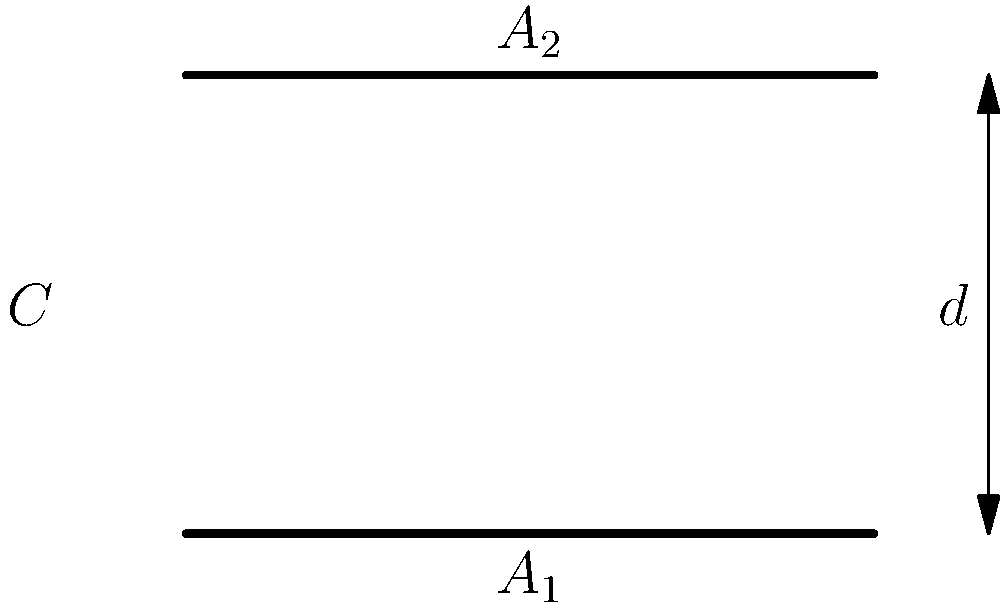A parallel plate capacitor has two rectangular plates with areas $A_1 = 100 \text{ cm}^2$ and $A_2 = 80 \text{ cm}^2$, separated by a distance $d = 2 \text{ mm}$. The dielectric between the plates is air (permittivity $\epsilon_0 = 8.85 \times 10^{-12} \text{ F/m}$). Calculate the capacitance of this system. How does this relate to the concept of overcrowding in prisons? To solve this problem, we'll follow these steps:

1) The capacitance of a parallel plate capacitor is given by the formula:

   $$C = \frac{\epsilon_0 A}{d}$$

   where $A$ is the effective area, $d$ is the distance between plates, and $\epsilon_0$ is the permittivity of free space.

2) In this case, the effective area is the smaller of the two plate areas, as this determines the maximum area of overlap. So, $A = A_2 = 80 \text{ cm}^2 = 80 \times 10^{-4} \text{ m}^2$.

3) We're given $d = 2 \text{ mm} = 2 \times 10^{-3} \text{ m}$ and $\epsilon_0 = 8.85 \times 10^{-12} \text{ F/m}$.

4) Substituting these values into the formula:

   $$C = \frac{(8.85 \times 10^{-12} \text{ F/m})(80 \times 10^{-4} \text{ m}^2)}{2 \times 10^{-3} \text{ m}}$$

5) Simplifying:

   $$C = 3.54 \times 10^{-11} \text{ F} = 35.4 \text{ pF}$$

This problem relates to overcrowding in prisons as it demonstrates how the smaller area (analogous to limited prison space) determines the overall capacity of the system, regardless of how large the other plate (analogous to the number of inmates) might be. Just as the capacitor's effectiveness is limited by its smaller plate, a prison system's ability to house inmates humanely is limited by its available space, not by the number of people sentenced to incarceration.
Answer: 35.4 pF 